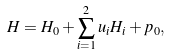<formula> <loc_0><loc_0><loc_500><loc_500>H = H _ { 0 } + \sum _ { i = 1 } ^ { 2 } u _ { i } H _ { i } + p _ { 0 } ,</formula> 